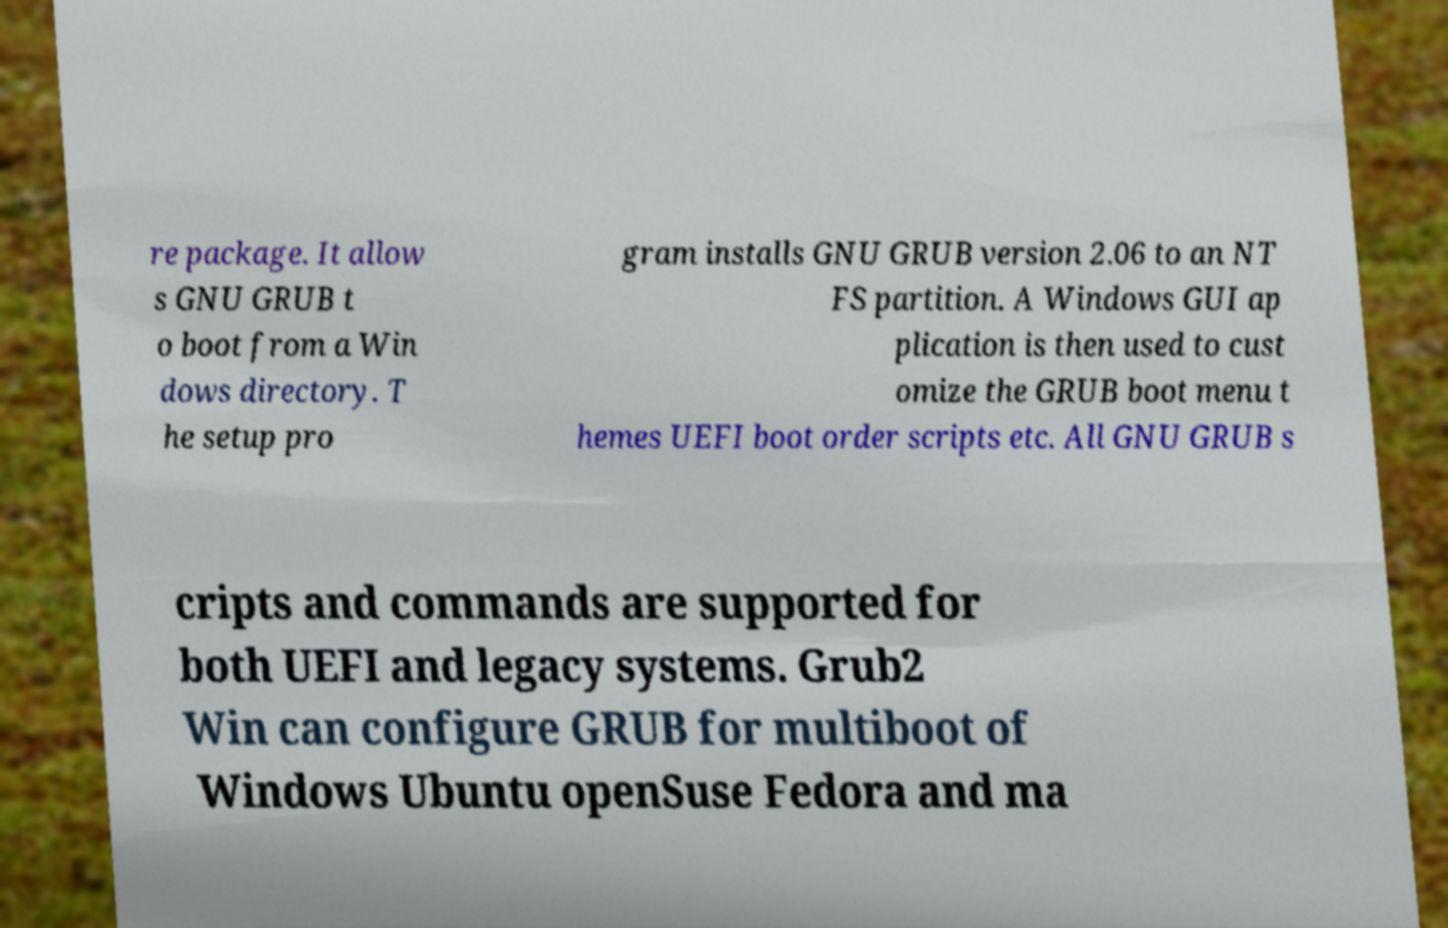Can you read and provide the text displayed in the image?This photo seems to have some interesting text. Can you extract and type it out for me? re package. It allow s GNU GRUB t o boot from a Win dows directory. T he setup pro gram installs GNU GRUB version 2.06 to an NT FS partition. A Windows GUI ap plication is then used to cust omize the GRUB boot menu t hemes UEFI boot order scripts etc. All GNU GRUB s cripts and commands are supported for both UEFI and legacy systems. Grub2 Win can configure GRUB for multiboot of Windows Ubuntu openSuse Fedora and ma 